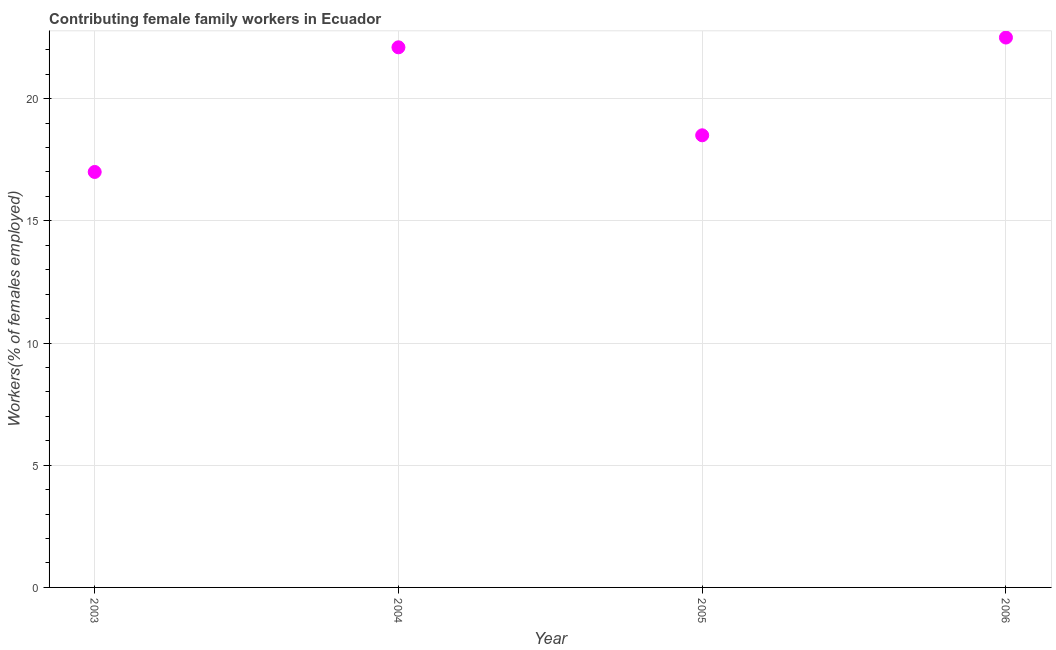What is the contributing female family workers in 2004?
Make the answer very short. 22.1. Across all years, what is the maximum contributing female family workers?
Give a very brief answer. 22.5. In which year was the contributing female family workers minimum?
Your answer should be very brief. 2003. What is the sum of the contributing female family workers?
Give a very brief answer. 80.1. What is the average contributing female family workers per year?
Provide a short and direct response. 20.03. What is the median contributing female family workers?
Your answer should be compact. 20.3. What is the ratio of the contributing female family workers in 2004 to that in 2005?
Offer a terse response. 1.19. Is the contributing female family workers in 2004 less than that in 2006?
Provide a short and direct response. Yes. What is the difference between the highest and the second highest contributing female family workers?
Provide a succinct answer. 0.4. Is the sum of the contributing female family workers in 2004 and 2006 greater than the maximum contributing female family workers across all years?
Keep it short and to the point. Yes. What is the difference between the highest and the lowest contributing female family workers?
Ensure brevity in your answer.  5.5. Does the contributing female family workers monotonically increase over the years?
Provide a short and direct response. No. How many dotlines are there?
Ensure brevity in your answer.  1. What is the difference between two consecutive major ticks on the Y-axis?
Keep it short and to the point. 5. Are the values on the major ticks of Y-axis written in scientific E-notation?
Your answer should be very brief. No. Does the graph contain any zero values?
Keep it short and to the point. No. What is the title of the graph?
Your answer should be compact. Contributing female family workers in Ecuador. What is the label or title of the X-axis?
Give a very brief answer. Year. What is the label or title of the Y-axis?
Offer a terse response. Workers(% of females employed). What is the Workers(% of females employed) in 2003?
Offer a terse response. 17. What is the Workers(% of females employed) in 2004?
Provide a short and direct response. 22.1. What is the difference between the Workers(% of females employed) in 2003 and 2004?
Keep it short and to the point. -5.1. What is the difference between the Workers(% of females employed) in 2003 and 2005?
Offer a terse response. -1.5. What is the difference between the Workers(% of females employed) in 2004 and 2005?
Your answer should be very brief. 3.6. What is the difference between the Workers(% of females employed) in 2004 and 2006?
Offer a terse response. -0.4. What is the difference between the Workers(% of females employed) in 2005 and 2006?
Keep it short and to the point. -4. What is the ratio of the Workers(% of females employed) in 2003 to that in 2004?
Ensure brevity in your answer.  0.77. What is the ratio of the Workers(% of females employed) in 2003 to that in 2005?
Ensure brevity in your answer.  0.92. What is the ratio of the Workers(% of females employed) in 2003 to that in 2006?
Provide a succinct answer. 0.76. What is the ratio of the Workers(% of females employed) in 2004 to that in 2005?
Provide a succinct answer. 1.2. What is the ratio of the Workers(% of females employed) in 2005 to that in 2006?
Offer a very short reply. 0.82. 